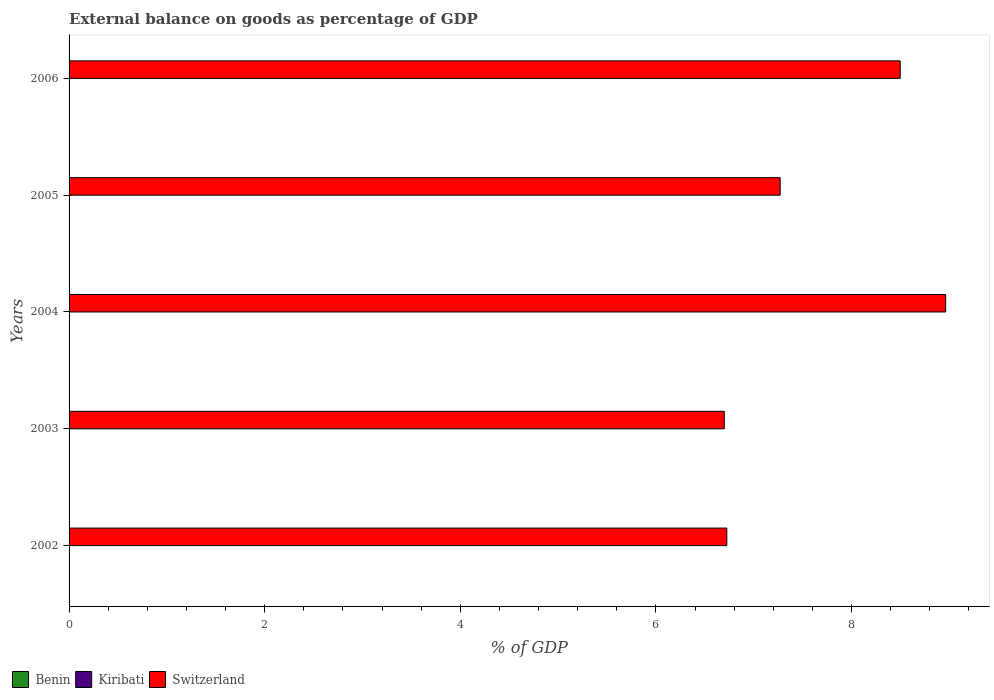Are the number of bars per tick equal to the number of legend labels?
Provide a short and direct response. No. Are the number of bars on each tick of the Y-axis equal?
Provide a succinct answer. Yes. How many bars are there on the 3rd tick from the bottom?
Provide a short and direct response. 1. What is the label of the 1st group of bars from the top?
Offer a very short reply. 2006. In how many cases, is the number of bars for a given year not equal to the number of legend labels?
Your response must be concise. 5. What is the external balance on goods as percentage of GDP in Switzerland in 2002?
Your response must be concise. 6.72. Across all years, what is the maximum external balance on goods as percentage of GDP in Switzerland?
Make the answer very short. 8.96. Across all years, what is the minimum external balance on goods as percentage of GDP in Kiribati?
Give a very brief answer. 0. What is the total external balance on goods as percentage of GDP in Switzerland in the graph?
Give a very brief answer. 38.15. What is the difference between the external balance on goods as percentage of GDP in Switzerland in 2005 and that in 2006?
Make the answer very short. -1.23. In how many years, is the external balance on goods as percentage of GDP in Switzerland greater than 6 %?
Your response must be concise. 5. What is the ratio of the external balance on goods as percentage of GDP in Switzerland in 2002 to that in 2006?
Make the answer very short. 0.79. What is the difference between the highest and the second highest external balance on goods as percentage of GDP in Switzerland?
Keep it short and to the point. 0.46. What is the difference between the highest and the lowest external balance on goods as percentage of GDP in Switzerland?
Offer a terse response. 2.26. Are all the bars in the graph horizontal?
Give a very brief answer. Yes. What is the difference between two consecutive major ticks on the X-axis?
Offer a very short reply. 2. Does the graph contain grids?
Keep it short and to the point. No. Where does the legend appear in the graph?
Your answer should be compact. Bottom left. How many legend labels are there?
Ensure brevity in your answer.  3. How are the legend labels stacked?
Offer a very short reply. Horizontal. What is the title of the graph?
Offer a very short reply. External balance on goods as percentage of GDP. Does "Korea (Republic)" appear as one of the legend labels in the graph?
Provide a short and direct response. No. What is the label or title of the X-axis?
Give a very brief answer. % of GDP. What is the label or title of the Y-axis?
Offer a terse response. Years. What is the % of GDP in Benin in 2002?
Provide a succinct answer. 0. What is the % of GDP of Switzerland in 2002?
Make the answer very short. 6.72. What is the % of GDP in Benin in 2003?
Your response must be concise. 0. What is the % of GDP of Kiribati in 2003?
Keep it short and to the point. 0. What is the % of GDP in Switzerland in 2003?
Provide a short and direct response. 6.7. What is the % of GDP in Benin in 2004?
Ensure brevity in your answer.  0. What is the % of GDP in Kiribati in 2004?
Your answer should be very brief. 0. What is the % of GDP in Switzerland in 2004?
Provide a short and direct response. 8.96. What is the % of GDP in Benin in 2005?
Your answer should be very brief. 0. What is the % of GDP of Switzerland in 2005?
Your answer should be very brief. 7.27. What is the % of GDP of Switzerland in 2006?
Provide a short and direct response. 8.5. Across all years, what is the maximum % of GDP in Switzerland?
Your answer should be compact. 8.96. Across all years, what is the minimum % of GDP of Switzerland?
Make the answer very short. 6.7. What is the total % of GDP in Switzerland in the graph?
Your response must be concise. 38.15. What is the difference between the % of GDP in Switzerland in 2002 and that in 2003?
Keep it short and to the point. 0.03. What is the difference between the % of GDP in Switzerland in 2002 and that in 2004?
Provide a short and direct response. -2.24. What is the difference between the % of GDP in Switzerland in 2002 and that in 2005?
Make the answer very short. -0.55. What is the difference between the % of GDP in Switzerland in 2002 and that in 2006?
Keep it short and to the point. -1.77. What is the difference between the % of GDP of Switzerland in 2003 and that in 2004?
Give a very brief answer. -2.26. What is the difference between the % of GDP of Switzerland in 2003 and that in 2005?
Provide a short and direct response. -0.57. What is the difference between the % of GDP in Switzerland in 2003 and that in 2006?
Your answer should be very brief. -1.8. What is the difference between the % of GDP in Switzerland in 2004 and that in 2005?
Your response must be concise. 1.69. What is the difference between the % of GDP of Switzerland in 2004 and that in 2006?
Your response must be concise. 0.46. What is the difference between the % of GDP of Switzerland in 2005 and that in 2006?
Offer a very short reply. -1.23. What is the average % of GDP of Switzerland per year?
Your answer should be very brief. 7.63. What is the ratio of the % of GDP of Switzerland in 2002 to that in 2004?
Your answer should be compact. 0.75. What is the ratio of the % of GDP of Switzerland in 2002 to that in 2005?
Offer a very short reply. 0.92. What is the ratio of the % of GDP of Switzerland in 2002 to that in 2006?
Keep it short and to the point. 0.79. What is the ratio of the % of GDP in Switzerland in 2003 to that in 2004?
Offer a terse response. 0.75. What is the ratio of the % of GDP of Switzerland in 2003 to that in 2005?
Provide a short and direct response. 0.92. What is the ratio of the % of GDP of Switzerland in 2003 to that in 2006?
Make the answer very short. 0.79. What is the ratio of the % of GDP in Switzerland in 2004 to that in 2005?
Offer a very short reply. 1.23. What is the ratio of the % of GDP in Switzerland in 2004 to that in 2006?
Keep it short and to the point. 1.05. What is the ratio of the % of GDP in Switzerland in 2005 to that in 2006?
Make the answer very short. 0.86. What is the difference between the highest and the second highest % of GDP of Switzerland?
Keep it short and to the point. 0.46. What is the difference between the highest and the lowest % of GDP in Switzerland?
Provide a succinct answer. 2.26. 